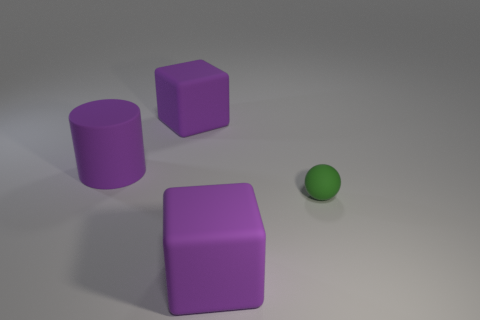There is a purple matte object that is on the right side of the purple matte cylinder and behind the tiny object; what size is it?
Keep it short and to the point. Large. Is the color of the large rubber block that is in front of the tiny green rubber object the same as the large matte cylinder?
Make the answer very short. Yes. Are there fewer big cylinders that are behind the small green rubber sphere than large purple cylinders?
Offer a very short reply. No. The small thing that is the same material as the cylinder is what shape?
Give a very brief answer. Sphere. Does the sphere have the same material as the cylinder?
Provide a succinct answer. Yes. Are there fewer green matte things behind the tiny thing than large rubber cylinders left of the purple cylinder?
Keep it short and to the point. No. There is a cube that is behind the rubber block in front of the green ball; how many green things are on the right side of it?
Your answer should be compact. 1. Is the color of the large cylinder the same as the small object?
Ensure brevity in your answer.  No. Are there any spheres that have the same color as the small object?
Give a very brief answer. No. Is there another tiny object of the same shape as the tiny rubber object?
Provide a succinct answer. No. 